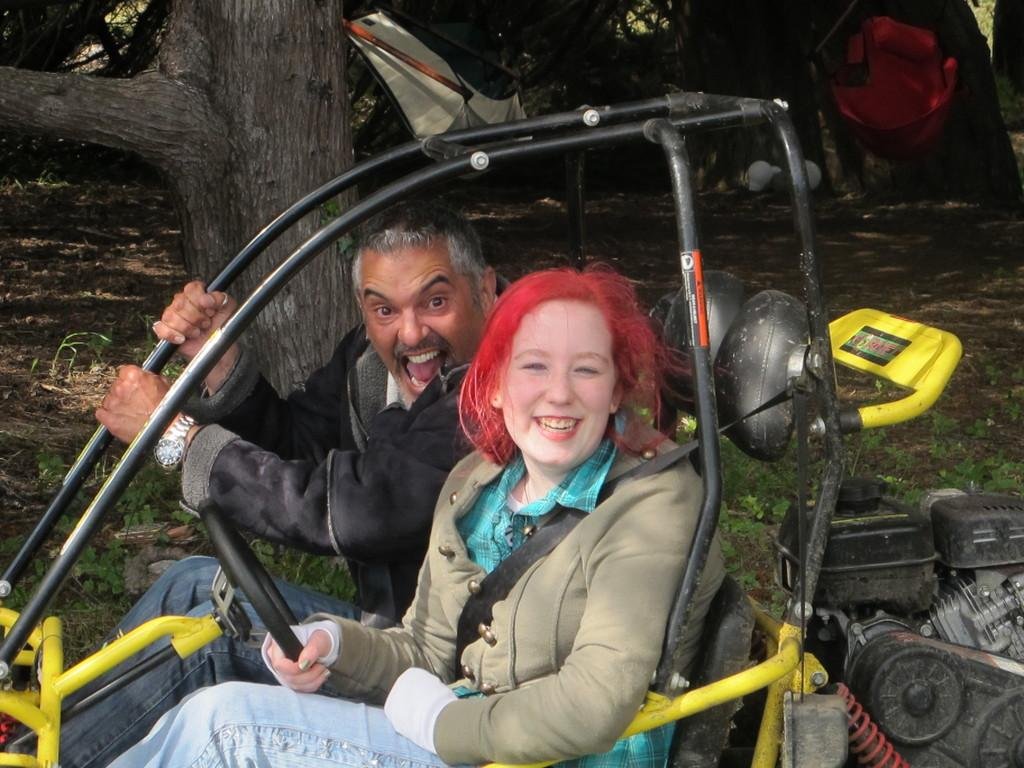Who is present in the image? There is a man and a woman in the image. What are the man and woman doing in the image? Both the man and woman are sitting in a vehicle. What can be seen in the background of the image? There are trees and other objects visible in the background of the image. What type of cord is the man holding in the image? There is no cord present in the image. Can you hear the horn of the vehicle in the image? The image is a still picture, so it does not include any sounds, such as a horn. 